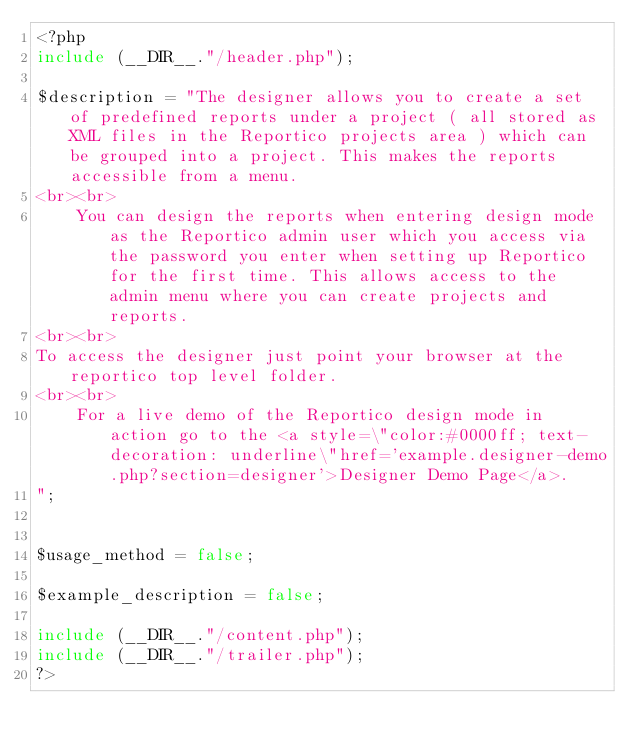<code> <loc_0><loc_0><loc_500><loc_500><_PHP_><?php
include (__DIR__."/header.php");

$description = "The designer allows you to create a set of predefined reports under a project ( all stored as XML files in the Reportico projects area ) which can be grouped into a project. This makes the reports accessible from a menu.
<br><br>
    You can design the reports when entering design mode as the Reportico admin user which you access via the password you enter when setting up Reportico for the first time. This allows access to the admin menu where you can create projects and reports.
<br><br>
To access the designer just point your browser at the reportico top level folder.
<br><br>
    For a live demo of the Reportico design mode in action go to the <a style=\"color:#0000ff; text-decoration: underline\"href='example.designer-demo.php?section=designer'>Designer Demo Page</a>.
";


$usage_method = false;

$example_description = false;

include (__DIR__."/content.php");
include (__DIR__."/trailer.php");
?>
</code> 